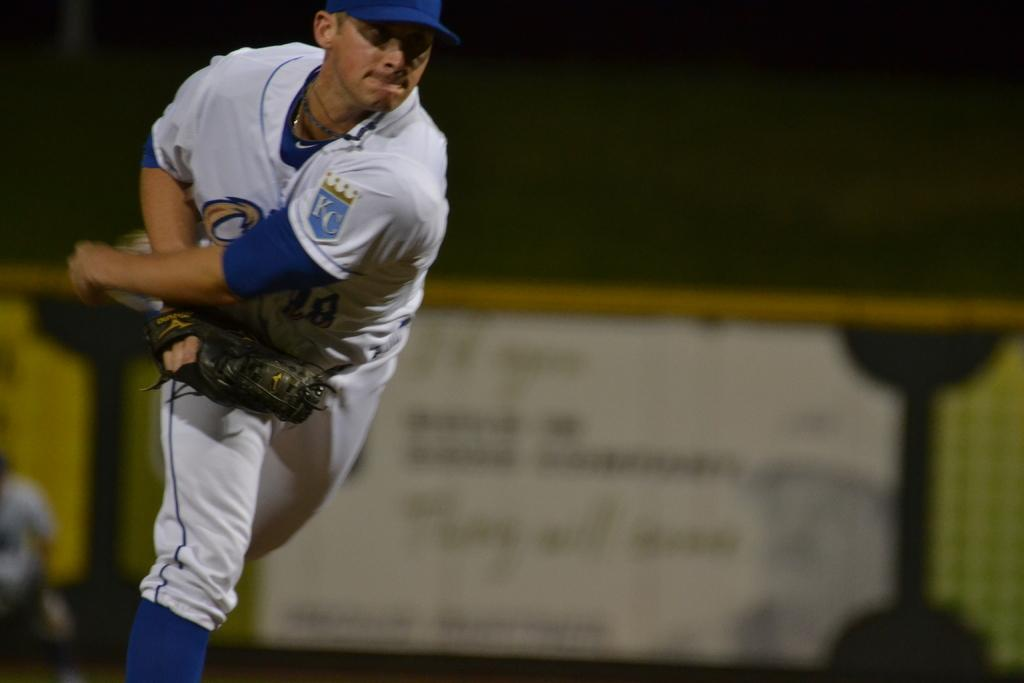<image>
Write a terse but informative summary of the picture. A man playing for Kansas City is throwing a baseball. 